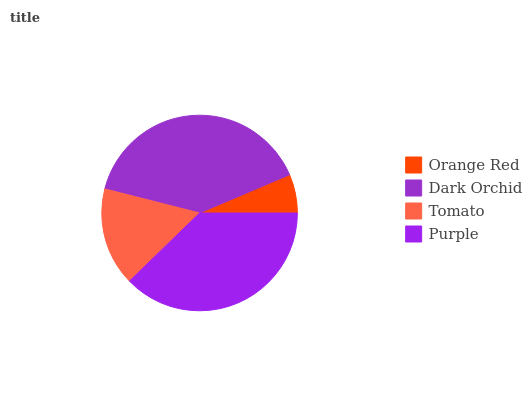Is Orange Red the minimum?
Answer yes or no. Yes. Is Dark Orchid the maximum?
Answer yes or no. Yes. Is Tomato the minimum?
Answer yes or no. No. Is Tomato the maximum?
Answer yes or no. No. Is Dark Orchid greater than Tomato?
Answer yes or no. Yes. Is Tomato less than Dark Orchid?
Answer yes or no. Yes. Is Tomato greater than Dark Orchid?
Answer yes or no. No. Is Dark Orchid less than Tomato?
Answer yes or no. No. Is Purple the high median?
Answer yes or no. Yes. Is Tomato the low median?
Answer yes or no. Yes. Is Tomato the high median?
Answer yes or no. No. Is Dark Orchid the low median?
Answer yes or no. No. 